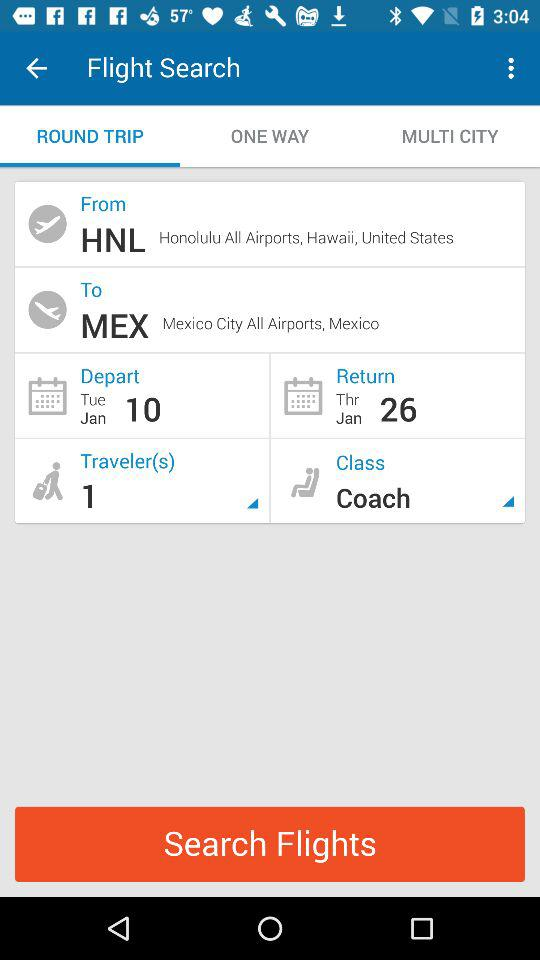How many more days are there between the departure date and the return date?
Answer the question using a single word or phrase. 16 